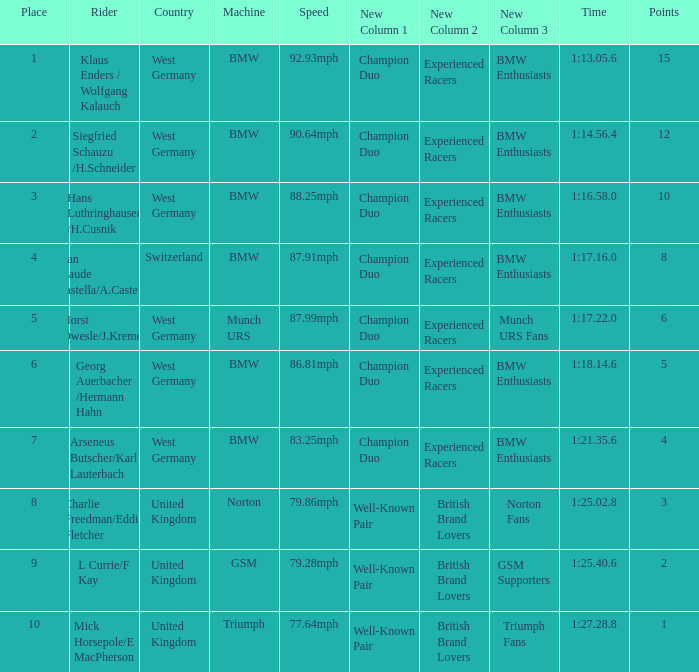Which places have points larger than 10? None. Can you give me this table as a dict? {'header': ['Place', 'Rider', 'Country', 'Machine', 'Speed', 'New Column 1', 'New Column 2', 'New Column 3', 'Time', 'Points'], 'rows': [['1', 'Klaus Enders / Wolfgang Kalauch', 'West Germany', 'BMW', '92.93mph', 'Champion Duo', 'Experienced Racers', 'BMW Enthusiasts', '1:13.05.6', '15'], ['2', 'Siegfried Schauzu /H.Schneider', 'West Germany', 'BMW', '90.64mph', 'Champion Duo', 'Experienced Racers', 'BMW Enthusiasts', '1:14.56.4', '12'], ['3', 'Hans Luthringhauser /H.Cusnik', 'West Germany', 'BMW', '88.25mph', 'Champion Duo', 'Experienced Racers', 'BMW Enthusiasts', '1:16.58.0', '10'], ['4', 'Jean Claude Castella/A.Castella', 'Switzerland', 'BMW', '87.91mph', 'Champion Duo', 'Experienced Racers', 'BMW Enthusiasts', '1:17.16.0', '8'], ['5', 'Horst Owesle/J.Kremer', 'West Germany', 'Munch URS', '87.99mph', 'Champion Duo', 'Experienced Racers', 'Munch URS Fans', '1:17.22.0', '6'], ['6', 'Georg Auerbacher /Hermann Hahn', 'West Germany', 'BMW', '86.81mph', 'Champion Duo', 'Experienced Racers', 'BMW Enthusiasts', '1:18.14.6', '5'], ['7', 'Arseneus Butscher/Karl Lauterbach', 'West Germany', 'BMW', '83.25mph', 'Champion Duo', 'Experienced Racers', 'BMW Enthusiasts', '1:21.35.6', '4'], ['8', 'Charlie Freedman/Eddie Fletcher', 'United Kingdom', 'Norton', '79.86mph', 'Well-Known Pair', 'British Brand Lovers', 'Norton Fans', '1:25.02.8', '3'], ['9', 'L Currie/F Kay', 'United Kingdom', 'GSM', '79.28mph', 'Well-Known Pair', 'British Brand Lovers', 'GSM Supporters', '1:25.40.6', '2'], ['10', 'Mick Horsepole/E MacPherson', 'United Kingdom', 'Triumph', '77.64mph', 'Well-Known Pair', 'British Brand Lovers', 'Triumph Fans', '1:27.28.8', '1']]} 